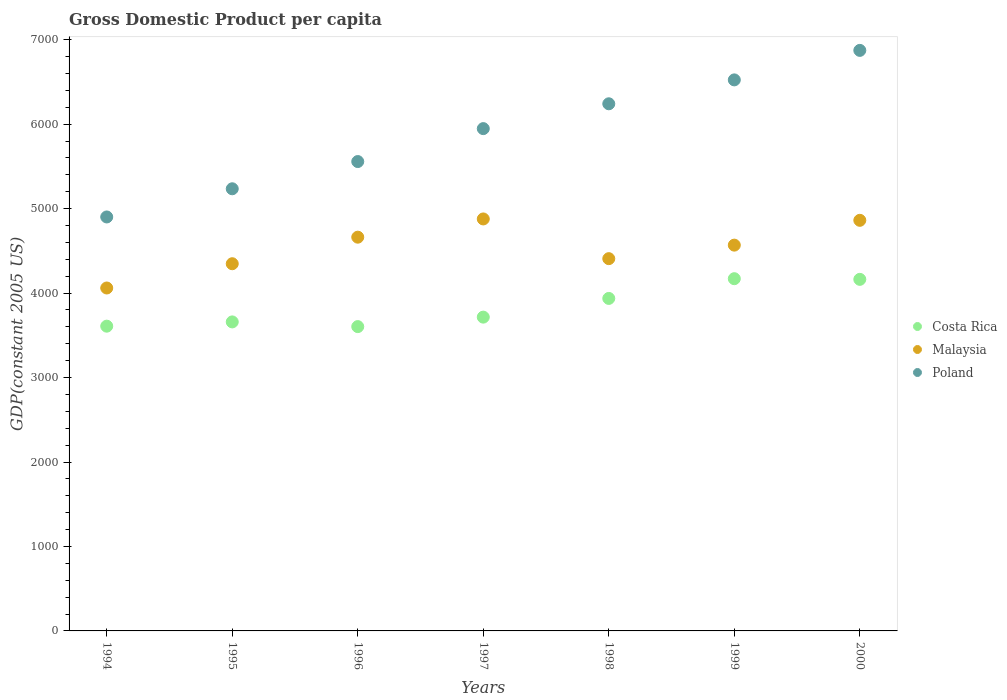How many different coloured dotlines are there?
Provide a short and direct response. 3. What is the GDP per capita in Costa Rica in 1994?
Your response must be concise. 3608.53. Across all years, what is the maximum GDP per capita in Costa Rica?
Make the answer very short. 4170.71. Across all years, what is the minimum GDP per capita in Costa Rica?
Provide a succinct answer. 3603.36. In which year was the GDP per capita in Malaysia minimum?
Provide a short and direct response. 1994. What is the total GDP per capita in Poland in the graph?
Your answer should be very brief. 4.13e+04. What is the difference between the GDP per capita in Costa Rica in 1996 and that in 1999?
Offer a terse response. -567.35. What is the difference between the GDP per capita in Poland in 1994 and the GDP per capita in Malaysia in 1995?
Provide a short and direct response. 553.85. What is the average GDP per capita in Malaysia per year?
Your answer should be compact. 4540.95. In the year 1996, what is the difference between the GDP per capita in Malaysia and GDP per capita in Costa Rica?
Offer a very short reply. 1058.93. In how many years, is the GDP per capita in Poland greater than 6000 US$?
Ensure brevity in your answer.  3. What is the ratio of the GDP per capita in Malaysia in 1996 to that in 1999?
Offer a very short reply. 1.02. Is the difference between the GDP per capita in Malaysia in 1998 and 2000 greater than the difference between the GDP per capita in Costa Rica in 1998 and 2000?
Offer a very short reply. No. What is the difference between the highest and the second highest GDP per capita in Costa Rica?
Provide a succinct answer. 7.88. What is the difference between the highest and the lowest GDP per capita in Costa Rica?
Make the answer very short. 567.35. In how many years, is the GDP per capita in Poland greater than the average GDP per capita in Poland taken over all years?
Your response must be concise. 4. Is the GDP per capita in Malaysia strictly greater than the GDP per capita in Poland over the years?
Offer a terse response. No. How many dotlines are there?
Ensure brevity in your answer.  3. Are the values on the major ticks of Y-axis written in scientific E-notation?
Offer a very short reply. No. How are the legend labels stacked?
Ensure brevity in your answer.  Vertical. What is the title of the graph?
Make the answer very short. Gross Domestic Product per capita. Does "Cuba" appear as one of the legend labels in the graph?
Offer a very short reply. No. What is the label or title of the X-axis?
Your answer should be compact. Years. What is the label or title of the Y-axis?
Your response must be concise. GDP(constant 2005 US). What is the GDP(constant 2005 US) in Costa Rica in 1994?
Your answer should be compact. 3608.53. What is the GDP(constant 2005 US) of Malaysia in 1994?
Ensure brevity in your answer.  4060.49. What is the GDP(constant 2005 US) of Poland in 1994?
Provide a short and direct response. 4901.7. What is the GDP(constant 2005 US) of Costa Rica in 1995?
Give a very brief answer. 3658.98. What is the GDP(constant 2005 US) of Malaysia in 1995?
Offer a very short reply. 4347.84. What is the GDP(constant 2005 US) of Poland in 1995?
Keep it short and to the point. 5235.35. What is the GDP(constant 2005 US) in Costa Rica in 1996?
Provide a succinct answer. 3603.36. What is the GDP(constant 2005 US) in Malaysia in 1996?
Offer a terse response. 4662.28. What is the GDP(constant 2005 US) of Poland in 1996?
Offer a terse response. 5557.75. What is the GDP(constant 2005 US) in Costa Rica in 1997?
Offer a very short reply. 3715.52. What is the GDP(constant 2005 US) of Malaysia in 1997?
Keep it short and to the point. 4878.13. What is the GDP(constant 2005 US) of Poland in 1997?
Your response must be concise. 5947.69. What is the GDP(constant 2005 US) in Costa Rica in 1998?
Offer a terse response. 3937.06. What is the GDP(constant 2005 US) of Malaysia in 1998?
Your response must be concise. 4407.96. What is the GDP(constant 2005 US) of Poland in 1998?
Ensure brevity in your answer.  6241.75. What is the GDP(constant 2005 US) of Costa Rica in 1999?
Make the answer very short. 4170.71. What is the GDP(constant 2005 US) in Malaysia in 1999?
Ensure brevity in your answer.  4568.08. What is the GDP(constant 2005 US) of Poland in 1999?
Make the answer very short. 6524.68. What is the GDP(constant 2005 US) in Costa Rica in 2000?
Provide a succinct answer. 4162.83. What is the GDP(constant 2005 US) in Malaysia in 2000?
Your answer should be very brief. 4861.89. What is the GDP(constant 2005 US) of Poland in 2000?
Provide a short and direct response. 6874.04. Across all years, what is the maximum GDP(constant 2005 US) of Costa Rica?
Your response must be concise. 4170.71. Across all years, what is the maximum GDP(constant 2005 US) of Malaysia?
Offer a very short reply. 4878.13. Across all years, what is the maximum GDP(constant 2005 US) of Poland?
Keep it short and to the point. 6874.04. Across all years, what is the minimum GDP(constant 2005 US) of Costa Rica?
Offer a terse response. 3603.36. Across all years, what is the minimum GDP(constant 2005 US) in Malaysia?
Give a very brief answer. 4060.49. Across all years, what is the minimum GDP(constant 2005 US) in Poland?
Offer a very short reply. 4901.7. What is the total GDP(constant 2005 US) in Costa Rica in the graph?
Provide a succinct answer. 2.69e+04. What is the total GDP(constant 2005 US) of Malaysia in the graph?
Make the answer very short. 3.18e+04. What is the total GDP(constant 2005 US) of Poland in the graph?
Offer a very short reply. 4.13e+04. What is the difference between the GDP(constant 2005 US) in Costa Rica in 1994 and that in 1995?
Provide a short and direct response. -50.45. What is the difference between the GDP(constant 2005 US) in Malaysia in 1994 and that in 1995?
Your answer should be compact. -287.35. What is the difference between the GDP(constant 2005 US) in Poland in 1994 and that in 1995?
Offer a very short reply. -333.65. What is the difference between the GDP(constant 2005 US) of Costa Rica in 1994 and that in 1996?
Offer a terse response. 5.18. What is the difference between the GDP(constant 2005 US) in Malaysia in 1994 and that in 1996?
Give a very brief answer. -601.79. What is the difference between the GDP(constant 2005 US) of Poland in 1994 and that in 1996?
Provide a succinct answer. -656.05. What is the difference between the GDP(constant 2005 US) in Costa Rica in 1994 and that in 1997?
Provide a succinct answer. -106.99. What is the difference between the GDP(constant 2005 US) of Malaysia in 1994 and that in 1997?
Provide a succinct answer. -817.63. What is the difference between the GDP(constant 2005 US) in Poland in 1994 and that in 1997?
Your answer should be very brief. -1045.99. What is the difference between the GDP(constant 2005 US) in Costa Rica in 1994 and that in 1998?
Provide a succinct answer. -328.53. What is the difference between the GDP(constant 2005 US) of Malaysia in 1994 and that in 1998?
Offer a terse response. -347.46. What is the difference between the GDP(constant 2005 US) in Poland in 1994 and that in 1998?
Keep it short and to the point. -1340.05. What is the difference between the GDP(constant 2005 US) in Costa Rica in 1994 and that in 1999?
Provide a succinct answer. -562.17. What is the difference between the GDP(constant 2005 US) of Malaysia in 1994 and that in 1999?
Ensure brevity in your answer.  -507.58. What is the difference between the GDP(constant 2005 US) in Poland in 1994 and that in 1999?
Your response must be concise. -1622.98. What is the difference between the GDP(constant 2005 US) of Costa Rica in 1994 and that in 2000?
Ensure brevity in your answer.  -554.29. What is the difference between the GDP(constant 2005 US) of Malaysia in 1994 and that in 2000?
Your response must be concise. -801.4. What is the difference between the GDP(constant 2005 US) in Poland in 1994 and that in 2000?
Offer a very short reply. -1972.34. What is the difference between the GDP(constant 2005 US) of Costa Rica in 1995 and that in 1996?
Offer a very short reply. 55.63. What is the difference between the GDP(constant 2005 US) of Malaysia in 1995 and that in 1996?
Ensure brevity in your answer.  -314.44. What is the difference between the GDP(constant 2005 US) of Poland in 1995 and that in 1996?
Give a very brief answer. -322.4. What is the difference between the GDP(constant 2005 US) in Costa Rica in 1995 and that in 1997?
Your answer should be compact. -56.54. What is the difference between the GDP(constant 2005 US) of Malaysia in 1995 and that in 1997?
Your answer should be very brief. -530.28. What is the difference between the GDP(constant 2005 US) of Poland in 1995 and that in 1997?
Your response must be concise. -712.34. What is the difference between the GDP(constant 2005 US) in Costa Rica in 1995 and that in 1998?
Your answer should be very brief. -278.08. What is the difference between the GDP(constant 2005 US) of Malaysia in 1995 and that in 1998?
Your response must be concise. -60.11. What is the difference between the GDP(constant 2005 US) of Poland in 1995 and that in 1998?
Make the answer very short. -1006.4. What is the difference between the GDP(constant 2005 US) in Costa Rica in 1995 and that in 1999?
Offer a very short reply. -511.72. What is the difference between the GDP(constant 2005 US) of Malaysia in 1995 and that in 1999?
Make the answer very short. -220.23. What is the difference between the GDP(constant 2005 US) in Poland in 1995 and that in 1999?
Ensure brevity in your answer.  -1289.33. What is the difference between the GDP(constant 2005 US) in Costa Rica in 1995 and that in 2000?
Your answer should be very brief. -503.84. What is the difference between the GDP(constant 2005 US) in Malaysia in 1995 and that in 2000?
Ensure brevity in your answer.  -514.04. What is the difference between the GDP(constant 2005 US) in Poland in 1995 and that in 2000?
Your response must be concise. -1638.69. What is the difference between the GDP(constant 2005 US) in Costa Rica in 1996 and that in 1997?
Your response must be concise. -112.17. What is the difference between the GDP(constant 2005 US) of Malaysia in 1996 and that in 1997?
Keep it short and to the point. -215.85. What is the difference between the GDP(constant 2005 US) of Poland in 1996 and that in 1997?
Your answer should be compact. -389.94. What is the difference between the GDP(constant 2005 US) in Costa Rica in 1996 and that in 1998?
Offer a terse response. -333.7. What is the difference between the GDP(constant 2005 US) of Malaysia in 1996 and that in 1998?
Make the answer very short. 254.32. What is the difference between the GDP(constant 2005 US) in Poland in 1996 and that in 1998?
Your answer should be compact. -684. What is the difference between the GDP(constant 2005 US) in Costa Rica in 1996 and that in 1999?
Provide a short and direct response. -567.35. What is the difference between the GDP(constant 2005 US) of Malaysia in 1996 and that in 1999?
Ensure brevity in your answer.  94.2. What is the difference between the GDP(constant 2005 US) of Poland in 1996 and that in 1999?
Offer a very short reply. -966.93. What is the difference between the GDP(constant 2005 US) in Costa Rica in 1996 and that in 2000?
Your answer should be very brief. -559.47. What is the difference between the GDP(constant 2005 US) in Malaysia in 1996 and that in 2000?
Keep it short and to the point. -199.61. What is the difference between the GDP(constant 2005 US) of Poland in 1996 and that in 2000?
Offer a terse response. -1316.29. What is the difference between the GDP(constant 2005 US) in Costa Rica in 1997 and that in 1998?
Make the answer very short. -221.53. What is the difference between the GDP(constant 2005 US) of Malaysia in 1997 and that in 1998?
Offer a terse response. 470.17. What is the difference between the GDP(constant 2005 US) in Poland in 1997 and that in 1998?
Your answer should be very brief. -294.06. What is the difference between the GDP(constant 2005 US) of Costa Rica in 1997 and that in 1999?
Offer a terse response. -455.18. What is the difference between the GDP(constant 2005 US) of Malaysia in 1997 and that in 1999?
Offer a very short reply. 310.05. What is the difference between the GDP(constant 2005 US) of Poland in 1997 and that in 1999?
Make the answer very short. -576.99. What is the difference between the GDP(constant 2005 US) of Costa Rica in 1997 and that in 2000?
Your answer should be very brief. -447.3. What is the difference between the GDP(constant 2005 US) of Malaysia in 1997 and that in 2000?
Provide a succinct answer. 16.24. What is the difference between the GDP(constant 2005 US) of Poland in 1997 and that in 2000?
Your answer should be very brief. -926.34. What is the difference between the GDP(constant 2005 US) of Costa Rica in 1998 and that in 1999?
Make the answer very short. -233.65. What is the difference between the GDP(constant 2005 US) of Malaysia in 1998 and that in 1999?
Give a very brief answer. -160.12. What is the difference between the GDP(constant 2005 US) in Poland in 1998 and that in 1999?
Keep it short and to the point. -282.93. What is the difference between the GDP(constant 2005 US) of Costa Rica in 1998 and that in 2000?
Keep it short and to the point. -225.77. What is the difference between the GDP(constant 2005 US) of Malaysia in 1998 and that in 2000?
Offer a very short reply. -453.93. What is the difference between the GDP(constant 2005 US) of Poland in 1998 and that in 2000?
Give a very brief answer. -632.28. What is the difference between the GDP(constant 2005 US) in Costa Rica in 1999 and that in 2000?
Offer a very short reply. 7.88. What is the difference between the GDP(constant 2005 US) in Malaysia in 1999 and that in 2000?
Offer a terse response. -293.81. What is the difference between the GDP(constant 2005 US) in Poland in 1999 and that in 2000?
Your response must be concise. -349.35. What is the difference between the GDP(constant 2005 US) in Costa Rica in 1994 and the GDP(constant 2005 US) in Malaysia in 1995?
Keep it short and to the point. -739.31. What is the difference between the GDP(constant 2005 US) of Costa Rica in 1994 and the GDP(constant 2005 US) of Poland in 1995?
Keep it short and to the point. -1626.82. What is the difference between the GDP(constant 2005 US) in Malaysia in 1994 and the GDP(constant 2005 US) in Poland in 1995?
Provide a succinct answer. -1174.85. What is the difference between the GDP(constant 2005 US) of Costa Rica in 1994 and the GDP(constant 2005 US) of Malaysia in 1996?
Provide a succinct answer. -1053.75. What is the difference between the GDP(constant 2005 US) of Costa Rica in 1994 and the GDP(constant 2005 US) of Poland in 1996?
Your response must be concise. -1949.21. What is the difference between the GDP(constant 2005 US) in Malaysia in 1994 and the GDP(constant 2005 US) in Poland in 1996?
Offer a very short reply. -1497.25. What is the difference between the GDP(constant 2005 US) in Costa Rica in 1994 and the GDP(constant 2005 US) in Malaysia in 1997?
Offer a terse response. -1269.6. What is the difference between the GDP(constant 2005 US) in Costa Rica in 1994 and the GDP(constant 2005 US) in Poland in 1997?
Your response must be concise. -2339.16. What is the difference between the GDP(constant 2005 US) of Malaysia in 1994 and the GDP(constant 2005 US) of Poland in 1997?
Provide a short and direct response. -1887.2. What is the difference between the GDP(constant 2005 US) of Costa Rica in 1994 and the GDP(constant 2005 US) of Malaysia in 1998?
Offer a terse response. -799.42. What is the difference between the GDP(constant 2005 US) of Costa Rica in 1994 and the GDP(constant 2005 US) of Poland in 1998?
Provide a succinct answer. -2633.22. What is the difference between the GDP(constant 2005 US) of Malaysia in 1994 and the GDP(constant 2005 US) of Poland in 1998?
Ensure brevity in your answer.  -2181.26. What is the difference between the GDP(constant 2005 US) of Costa Rica in 1994 and the GDP(constant 2005 US) of Malaysia in 1999?
Offer a very short reply. -959.55. What is the difference between the GDP(constant 2005 US) in Costa Rica in 1994 and the GDP(constant 2005 US) in Poland in 1999?
Your response must be concise. -2916.15. What is the difference between the GDP(constant 2005 US) of Malaysia in 1994 and the GDP(constant 2005 US) of Poland in 1999?
Offer a terse response. -2464.19. What is the difference between the GDP(constant 2005 US) of Costa Rica in 1994 and the GDP(constant 2005 US) of Malaysia in 2000?
Give a very brief answer. -1253.36. What is the difference between the GDP(constant 2005 US) in Costa Rica in 1994 and the GDP(constant 2005 US) in Poland in 2000?
Offer a very short reply. -3265.5. What is the difference between the GDP(constant 2005 US) of Malaysia in 1994 and the GDP(constant 2005 US) of Poland in 2000?
Offer a terse response. -2813.54. What is the difference between the GDP(constant 2005 US) of Costa Rica in 1995 and the GDP(constant 2005 US) of Malaysia in 1996?
Your answer should be compact. -1003.3. What is the difference between the GDP(constant 2005 US) of Costa Rica in 1995 and the GDP(constant 2005 US) of Poland in 1996?
Your response must be concise. -1898.77. What is the difference between the GDP(constant 2005 US) of Malaysia in 1995 and the GDP(constant 2005 US) of Poland in 1996?
Make the answer very short. -1209.9. What is the difference between the GDP(constant 2005 US) of Costa Rica in 1995 and the GDP(constant 2005 US) of Malaysia in 1997?
Your response must be concise. -1219.15. What is the difference between the GDP(constant 2005 US) of Costa Rica in 1995 and the GDP(constant 2005 US) of Poland in 1997?
Provide a succinct answer. -2288.71. What is the difference between the GDP(constant 2005 US) of Malaysia in 1995 and the GDP(constant 2005 US) of Poland in 1997?
Provide a succinct answer. -1599.85. What is the difference between the GDP(constant 2005 US) in Costa Rica in 1995 and the GDP(constant 2005 US) in Malaysia in 1998?
Your answer should be compact. -748.98. What is the difference between the GDP(constant 2005 US) of Costa Rica in 1995 and the GDP(constant 2005 US) of Poland in 1998?
Your answer should be compact. -2582.77. What is the difference between the GDP(constant 2005 US) of Malaysia in 1995 and the GDP(constant 2005 US) of Poland in 1998?
Your response must be concise. -1893.91. What is the difference between the GDP(constant 2005 US) of Costa Rica in 1995 and the GDP(constant 2005 US) of Malaysia in 1999?
Your answer should be compact. -909.1. What is the difference between the GDP(constant 2005 US) of Costa Rica in 1995 and the GDP(constant 2005 US) of Poland in 1999?
Make the answer very short. -2865.7. What is the difference between the GDP(constant 2005 US) of Malaysia in 1995 and the GDP(constant 2005 US) of Poland in 1999?
Offer a terse response. -2176.84. What is the difference between the GDP(constant 2005 US) of Costa Rica in 1995 and the GDP(constant 2005 US) of Malaysia in 2000?
Make the answer very short. -1202.91. What is the difference between the GDP(constant 2005 US) in Costa Rica in 1995 and the GDP(constant 2005 US) in Poland in 2000?
Make the answer very short. -3215.05. What is the difference between the GDP(constant 2005 US) of Malaysia in 1995 and the GDP(constant 2005 US) of Poland in 2000?
Keep it short and to the point. -2526.19. What is the difference between the GDP(constant 2005 US) in Costa Rica in 1996 and the GDP(constant 2005 US) in Malaysia in 1997?
Give a very brief answer. -1274.77. What is the difference between the GDP(constant 2005 US) of Costa Rica in 1996 and the GDP(constant 2005 US) of Poland in 1997?
Keep it short and to the point. -2344.34. What is the difference between the GDP(constant 2005 US) of Malaysia in 1996 and the GDP(constant 2005 US) of Poland in 1997?
Ensure brevity in your answer.  -1285.41. What is the difference between the GDP(constant 2005 US) of Costa Rica in 1996 and the GDP(constant 2005 US) of Malaysia in 1998?
Your answer should be very brief. -804.6. What is the difference between the GDP(constant 2005 US) of Costa Rica in 1996 and the GDP(constant 2005 US) of Poland in 1998?
Your response must be concise. -2638.4. What is the difference between the GDP(constant 2005 US) in Malaysia in 1996 and the GDP(constant 2005 US) in Poland in 1998?
Provide a succinct answer. -1579.47. What is the difference between the GDP(constant 2005 US) in Costa Rica in 1996 and the GDP(constant 2005 US) in Malaysia in 1999?
Offer a very short reply. -964.72. What is the difference between the GDP(constant 2005 US) in Costa Rica in 1996 and the GDP(constant 2005 US) in Poland in 1999?
Keep it short and to the point. -2921.33. What is the difference between the GDP(constant 2005 US) in Malaysia in 1996 and the GDP(constant 2005 US) in Poland in 1999?
Give a very brief answer. -1862.4. What is the difference between the GDP(constant 2005 US) in Costa Rica in 1996 and the GDP(constant 2005 US) in Malaysia in 2000?
Make the answer very short. -1258.53. What is the difference between the GDP(constant 2005 US) in Costa Rica in 1996 and the GDP(constant 2005 US) in Poland in 2000?
Provide a short and direct response. -3270.68. What is the difference between the GDP(constant 2005 US) in Malaysia in 1996 and the GDP(constant 2005 US) in Poland in 2000?
Offer a very short reply. -2211.75. What is the difference between the GDP(constant 2005 US) of Costa Rica in 1997 and the GDP(constant 2005 US) of Malaysia in 1998?
Provide a succinct answer. -692.43. What is the difference between the GDP(constant 2005 US) of Costa Rica in 1997 and the GDP(constant 2005 US) of Poland in 1998?
Offer a terse response. -2526.23. What is the difference between the GDP(constant 2005 US) in Malaysia in 1997 and the GDP(constant 2005 US) in Poland in 1998?
Ensure brevity in your answer.  -1363.62. What is the difference between the GDP(constant 2005 US) in Costa Rica in 1997 and the GDP(constant 2005 US) in Malaysia in 1999?
Your answer should be compact. -852.55. What is the difference between the GDP(constant 2005 US) in Costa Rica in 1997 and the GDP(constant 2005 US) in Poland in 1999?
Keep it short and to the point. -2809.16. What is the difference between the GDP(constant 2005 US) of Malaysia in 1997 and the GDP(constant 2005 US) of Poland in 1999?
Offer a terse response. -1646.55. What is the difference between the GDP(constant 2005 US) in Costa Rica in 1997 and the GDP(constant 2005 US) in Malaysia in 2000?
Keep it short and to the point. -1146.36. What is the difference between the GDP(constant 2005 US) in Costa Rica in 1997 and the GDP(constant 2005 US) in Poland in 2000?
Give a very brief answer. -3158.51. What is the difference between the GDP(constant 2005 US) of Malaysia in 1997 and the GDP(constant 2005 US) of Poland in 2000?
Your answer should be very brief. -1995.91. What is the difference between the GDP(constant 2005 US) of Costa Rica in 1998 and the GDP(constant 2005 US) of Malaysia in 1999?
Your answer should be compact. -631.02. What is the difference between the GDP(constant 2005 US) of Costa Rica in 1998 and the GDP(constant 2005 US) of Poland in 1999?
Offer a very short reply. -2587.62. What is the difference between the GDP(constant 2005 US) of Malaysia in 1998 and the GDP(constant 2005 US) of Poland in 1999?
Your response must be concise. -2116.73. What is the difference between the GDP(constant 2005 US) of Costa Rica in 1998 and the GDP(constant 2005 US) of Malaysia in 2000?
Make the answer very short. -924.83. What is the difference between the GDP(constant 2005 US) in Costa Rica in 1998 and the GDP(constant 2005 US) in Poland in 2000?
Ensure brevity in your answer.  -2936.98. What is the difference between the GDP(constant 2005 US) of Malaysia in 1998 and the GDP(constant 2005 US) of Poland in 2000?
Your answer should be compact. -2466.08. What is the difference between the GDP(constant 2005 US) in Costa Rica in 1999 and the GDP(constant 2005 US) in Malaysia in 2000?
Your response must be concise. -691.18. What is the difference between the GDP(constant 2005 US) in Costa Rica in 1999 and the GDP(constant 2005 US) in Poland in 2000?
Your response must be concise. -2703.33. What is the difference between the GDP(constant 2005 US) of Malaysia in 1999 and the GDP(constant 2005 US) of Poland in 2000?
Provide a short and direct response. -2305.96. What is the average GDP(constant 2005 US) in Costa Rica per year?
Keep it short and to the point. 3836.71. What is the average GDP(constant 2005 US) in Malaysia per year?
Keep it short and to the point. 4540.95. What is the average GDP(constant 2005 US) in Poland per year?
Your answer should be compact. 5897.57. In the year 1994, what is the difference between the GDP(constant 2005 US) in Costa Rica and GDP(constant 2005 US) in Malaysia?
Make the answer very short. -451.96. In the year 1994, what is the difference between the GDP(constant 2005 US) in Costa Rica and GDP(constant 2005 US) in Poland?
Offer a very short reply. -1293.17. In the year 1994, what is the difference between the GDP(constant 2005 US) of Malaysia and GDP(constant 2005 US) of Poland?
Keep it short and to the point. -841.21. In the year 1995, what is the difference between the GDP(constant 2005 US) in Costa Rica and GDP(constant 2005 US) in Malaysia?
Provide a succinct answer. -688.86. In the year 1995, what is the difference between the GDP(constant 2005 US) of Costa Rica and GDP(constant 2005 US) of Poland?
Ensure brevity in your answer.  -1576.37. In the year 1995, what is the difference between the GDP(constant 2005 US) in Malaysia and GDP(constant 2005 US) in Poland?
Your response must be concise. -887.5. In the year 1996, what is the difference between the GDP(constant 2005 US) of Costa Rica and GDP(constant 2005 US) of Malaysia?
Ensure brevity in your answer.  -1058.93. In the year 1996, what is the difference between the GDP(constant 2005 US) of Costa Rica and GDP(constant 2005 US) of Poland?
Offer a very short reply. -1954.39. In the year 1996, what is the difference between the GDP(constant 2005 US) in Malaysia and GDP(constant 2005 US) in Poland?
Offer a terse response. -895.47. In the year 1997, what is the difference between the GDP(constant 2005 US) in Costa Rica and GDP(constant 2005 US) in Malaysia?
Ensure brevity in your answer.  -1162.6. In the year 1997, what is the difference between the GDP(constant 2005 US) of Costa Rica and GDP(constant 2005 US) of Poland?
Provide a short and direct response. -2232.17. In the year 1997, what is the difference between the GDP(constant 2005 US) of Malaysia and GDP(constant 2005 US) of Poland?
Your response must be concise. -1069.56. In the year 1998, what is the difference between the GDP(constant 2005 US) of Costa Rica and GDP(constant 2005 US) of Malaysia?
Ensure brevity in your answer.  -470.9. In the year 1998, what is the difference between the GDP(constant 2005 US) in Costa Rica and GDP(constant 2005 US) in Poland?
Your answer should be very brief. -2304.69. In the year 1998, what is the difference between the GDP(constant 2005 US) in Malaysia and GDP(constant 2005 US) in Poland?
Provide a succinct answer. -1833.79. In the year 1999, what is the difference between the GDP(constant 2005 US) of Costa Rica and GDP(constant 2005 US) of Malaysia?
Keep it short and to the point. -397.37. In the year 1999, what is the difference between the GDP(constant 2005 US) in Costa Rica and GDP(constant 2005 US) in Poland?
Offer a terse response. -2353.98. In the year 1999, what is the difference between the GDP(constant 2005 US) in Malaysia and GDP(constant 2005 US) in Poland?
Keep it short and to the point. -1956.6. In the year 2000, what is the difference between the GDP(constant 2005 US) of Costa Rica and GDP(constant 2005 US) of Malaysia?
Make the answer very short. -699.06. In the year 2000, what is the difference between the GDP(constant 2005 US) in Costa Rica and GDP(constant 2005 US) in Poland?
Give a very brief answer. -2711.21. In the year 2000, what is the difference between the GDP(constant 2005 US) of Malaysia and GDP(constant 2005 US) of Poland?
Ensure brevity in your answer.  -2012.15. What is the ratio of the GDP(constant 2005 US) of Costa Rica in 1994 to that in 1995?
Give a very brief answer. 0.99. What is the ratio of the GDP(constant 2005 US) in Malaysia in 1994 to that in 1995?
Your response must be concise. 0.93. What is the ratio of the GDP(constant 2005 US) of Poland in 1994 to that in 1995?
Ensure brevity in your answer.  0.94. What is the ratio of the GDP(constant 2005 US) in Malaysia in 1994 to that in 1996?
Offer a very short reply. 0.87. What is the ratio of the GDP(constant 2005 US) of Poland in 1994 to that in 1996?
Offer a terse response. 0.88. What is the ratio of the GDP(constant 2005 US) in Costa Rica in 1994 to that in 1997?
Your answer should be compact. 0.97. What is the ratio of the GDP(constant 2005 US) of Malaysia in 1994 to that in 1997?
Give a very brief answer. 0.83. What is the ratio of the GDP(constant 2005 US) of Poland in 1994 to that in 1997?
Offer a very short reply. 0.82. What is the ratio of the GDP(constant 2005 US) of Costa Rica in 1994 to that in 1998?
Give a very brief answer. 0.92. What is the ratio of the GDP(constant 2005 US) of Malaysia in 1994 to that in 1998?
Keep it short and to the point. 0.92. What is the ratio of the GDP(constant 2005 US) of Poland in 1994 to that in 1998?
Your response must be concise. 0.79. What is the ratio of the GDP(constant 2005 US) in Costa Rica in 1994 to that in 1999?
Your answer should be very brief. 0.87. What is the ratio of the GDP(constant 2005 US) of Malaysia in 1994 to that in 1999?
Your response must be concise. 0.89. What is the ratio of the GDP(constant 2005 US) in Poland in 1994 to that in 1999?
Your answer should be compact. 0.75. What is the ratio of the GDP(constant 2005 US) in Costa Rica in 1994 to that in 2000?
Your answer should be very brief. 0.87. What is the ratio of the GDP(constant 2005 US) in Malaysia in 1994 to that in 2000?
Offer a terse response. 0.84. What is the ratio of the GDP(constant 2005 US) of Poland in 1994 to that in 2000?
Ensure brevity in your answer.  0.71. What is the ratio of the GDP(constant 2005 US) of Costa Rica in 1995 to that in 1996?
Give a very brief answer. 1.02. What is the ratio of the GDP(constant 2005 US) in Malaysia in 1995 to that in 1996?
Give a very brief answer. 0.93. What is the ratio of the GDP(constant 2005 US) of Poland in 1995 to that in 1996?
Offer a terse response. 0.94. What is the ratio of the GDP(constant 2005 US) of Malaysia in 1995 to that in 1997?
Offer a terse response. 0.89. What is the ratio of the GDP(constant 2005 US) in Poland in 1995 to that in 1997?
Provide a short and direct response. 0.88. What is the ratio of the GDP(constant 2005 US) of Costa Rica in 1995 to that in 1998?
Ensure brevity in your answer.  0.93. What is the ratio of the GDP(constant 2005 US) of Malaysia in 1995 to that in 1998?
Ensure brevity in your answer.  0.99. What is the ratio of the GDP(constant 2005 US) in Poland in 1995 to that in 1998?
Ensure brevity in your answer.  0.84. What is the ratio of the GDP(constant 2005 US) in Costa Rica in 1995 to that in 1999?
Your response must be concise. 0.88. What is the ratio of the GDP(constant 2005 US) of Malaysia in 1995 to that in 1999?
Give a very brief answer. 0.95. What is the ratio of the GDP(constant 2005 US) in Poland in 1995 to that in 1999?
Your answer should be compact. 0.8. What is the ratio of the GDP(constant 2005 US) of Costa Rica in 1995 to that in 2000?
Offer a very short reply. 0.88. What is the ratio of the GDP(constant 2005 US) of Malaysia in 1995 to that in 2000?
Your answer should be very brief. 0.89. What is the ratio of the GDP(constant 2005 US) of Poland in 1995 to that in 2000?
Your answer should be compact. 0.76. What is the ratio of the GDP(constant 2005 US) of Costa Rica in 1996 to that in 1997?
Your answer should be compact. 0.97. What is the ratio of the GDP(constant 2005 US) of Malaysia in 1996 to that in 1997?
Your response must be concise. 0.96. What is the ratio of the GDP(constant 2005 US) in Poland in 1996 to that in 1997?
Your response must be concise. 0.93. What is the ratio of the GDP(constant 2005 US) of Costa Rica in 1996 to that in 1998?
Give a very brief answer. 0.92. What is the ratio of the GDP(constant 2005 US) of Malaysia in 1996 to that in 1998?
Keep it short and to the point. 1.06. What is the ratio of the GDP(constant 2005 US) of Poland in 1996 to that in 1998?
Offer a very short reply. 0.89. What is the ratio of the GDP(constant 2005 US) in Costa Rica in 1996 to that in 1999?
Make the answer very short. 0.86. What is the ratio of the GDP(constant 2005 US) of Malaysia in 1996 to that in 1999?
Provide a short and direct response. 1.02. What is the ratio of the GDP(constant 2005 US) in Poland in 1996 to that in 1999?
Offer a terse response. 0.85. What is the ratio of the GDP(constant 2005 US) of Costa Rica in 1996 to that in 2000?
Make the answer very short. 0.87. What is the ratio of the GDP(constant 2005 US) of Malaysia in 1996 to that in 2000?
Your answer should be very brief. 0.96. What is the ratio of the GDP(constant 2005 US) of Poland in 1996 to that in 2000?
Your answer should be very brief. 0.81. What is the ratio of the GDP(constant 2005 US) of Costa Rica in 1997 to that in 1998?
Make the answer very short. 0.94. What is the ratio of the GDP(constant 2005 US) in Malaysia in 1997 to that in 1998?
Provide a succinct answer. 1.11. What is the ratio of the GDP(constant 2005 US) of Poland in 1997 to that in 1998?
Keep it short and to the point. 0.95. What is the ratio of the GDP(constant 2005 US) of Costa Rica in 1997 to that in 1999?
Offer a terse response. 0.89. What is the ratio of the GDP(constant 2005 US) in Malaysia in 1997 to that in 1999?
Provide a succinct answer. 1.07. What is the ratio of the GDP(constant 2005 US) of Poland in 1997 to that in 1999?
Your answer should be compact. 0.91. What is the ratio of the GDP(constant 2005 US) in Costa Rica in 1997 to that in 2000?
Your response must be concise. 0.89. What is the ratio of the GDP(constant 2005 US) of Poland in 1997 to that in 2000?
Your response must be concise. 0.87. What is the ratio of the GDP(constant 2005 US) in Costa Rica in 1998 to that in 1999?
Provide a succinct answer. 0.94. What is the ratio of the GDP(constant 2005 US) of Malaysia in 1998 to that in 1999?
Provide a succinct answer. 0.96. What is the ratio of the GDP(constant 2005 US) of Poland in 1998 to that in 1999?
Ensure brevity in your answer.  0.96. What is the ratio of the GDP(constant 2005 US) of Costa Rica in 1998 to that in 2000?
Make the answer very short. 0.95. What is the ratio of the GDP(constant 2005 US) of Malaysia in 1998 to that in 2000?
Your answer should be compact. 0.91. What is the ratio of the GDP(constant 2005 US) in Poland in 1998 to that in 2000?
Your response must be concise. 0.91. What is the ratio of the GDP(constant 2005 US) of Costa Rica in 1999 to that in 2000?
Provide a short and direct response. 1. What is the ratio of the GDP(constant 2005 US) of Malaysia in 1999 to that in 2000?
Your answer should be compact. 0.94. What is the ratio of the GDP(constant 2005 US) of Poland in 1999 to that in 2000?
Make the answer very short. 0.95. What is the difference between the highest and the second highest GDP(constant 2005 US) in Costa Rica?
Provide a succinct answer. 7.88. What is the difference between the highest and the second highest GDP(constant 2005 US) of Malaysia?
Offer a very short reply. 16.24. What is the difference between the highest and the second highest GDP(constant 2005 US) in Poland?
Offer a very short reply. 349.35. What is the difference between the highest and the lowest GDP(constant 2005 US) in Costa Rica?
Your response must be concise. 567.35. What is the difference between the highest and the lowest GDP(constant 2005 US) in Malaysia?
Make the answer very short. 817.63. What is the difference between the highest and the lowest GDP(constant 2005 US) in Poland?
Provide a short and direct response. 1972.34. 